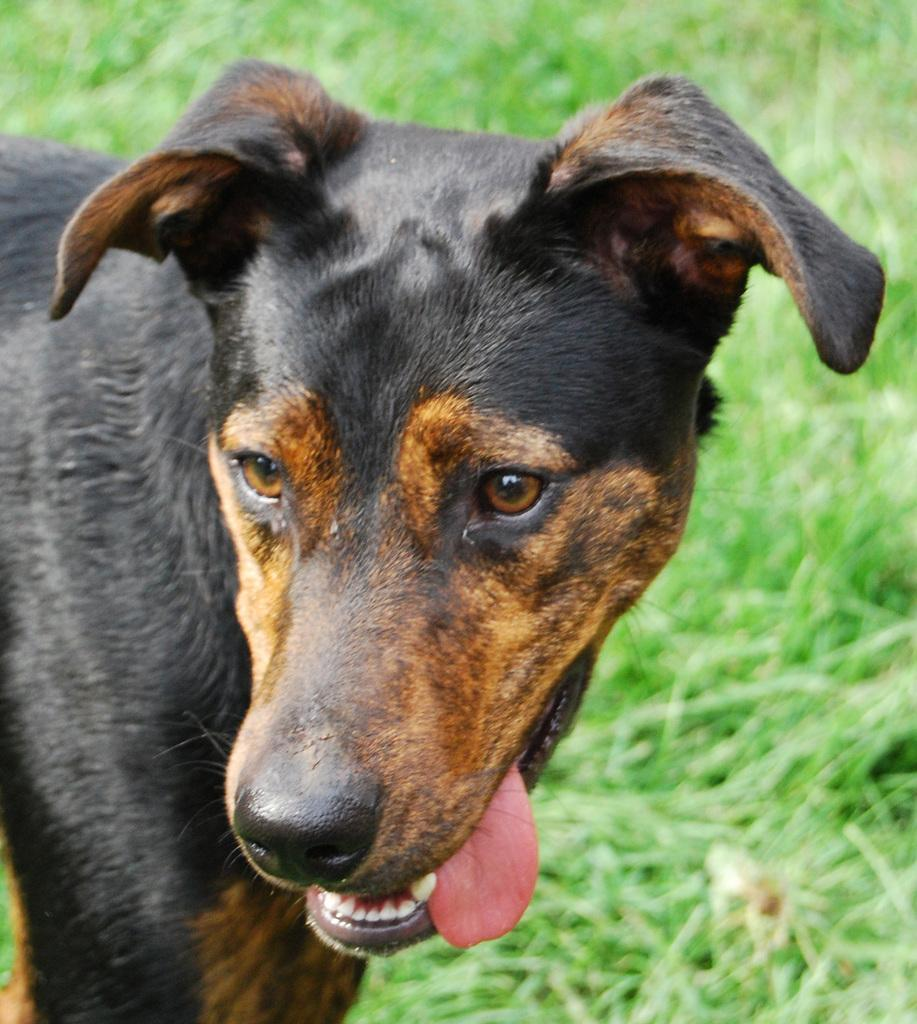What animal is present in the image? There is a dog in the image. What colors can be seen on the dog? The dog is black and brown in color. What type of surface is the dog standing on? The dog is standing on the grass. What type of glove is the monkey wearing in the image? There is no monkey or glove present in the image; it features a dog standing on the grass. 